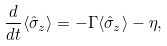<formula> <loc_0><loc_0><loc_500><loc_500>\frac { d } { d t } \langle \hat { \sigma } _ { z } \rangle = - \Gamma \langle \hat { \sigma } _ { z } \rangle - \eta ,</formula> 